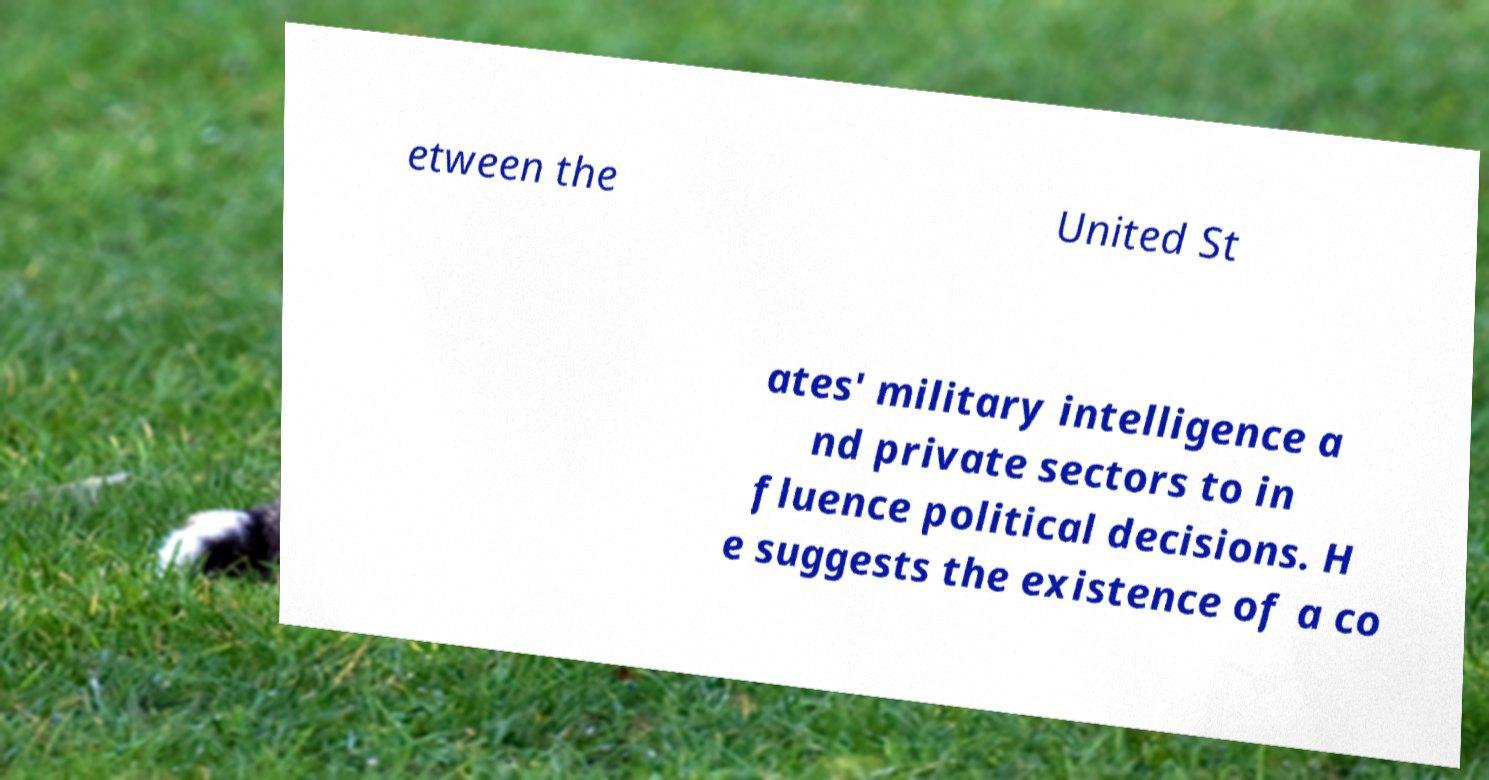There's text embedded in this image that I need extracted. Can you transcribe it verbatim? etween the United St ates' military intelligence a nd private sectors to in fluence political decisions. H e suggests the existence of a co 